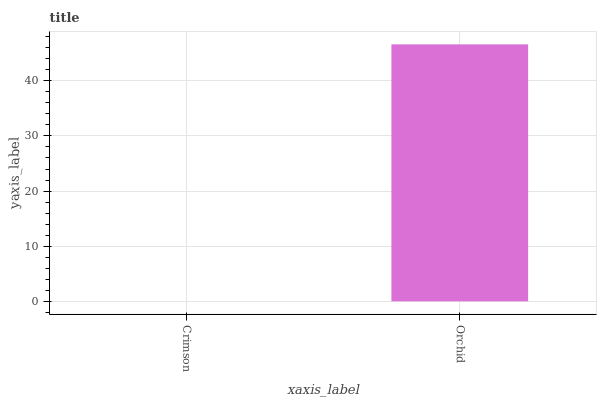Is Crimson the minimum?
Answer yes or no. Yes. Is Orchid the maximum?
Answer yes or no. Yes. Is Orchid the minimum?
Answer yes or no. No. Is Orchid greater than Crimson?
Answer yes or no. Yes. Is Crimson less than Orchid?
Answer yes or no. Yes. Is Crimson greater than Orchid?
Answer yes or no. No. Is Orchid less than Crimson?
Answer yes or no. No. Is Orchid the high median?
Answer yes or no. Yes. Is Crimson the low median?
Answer yes or no. Yes. Is Crimson the high median?
Answer yes or no. No. Is Orchid the low median?
Answer yes or no. No. 